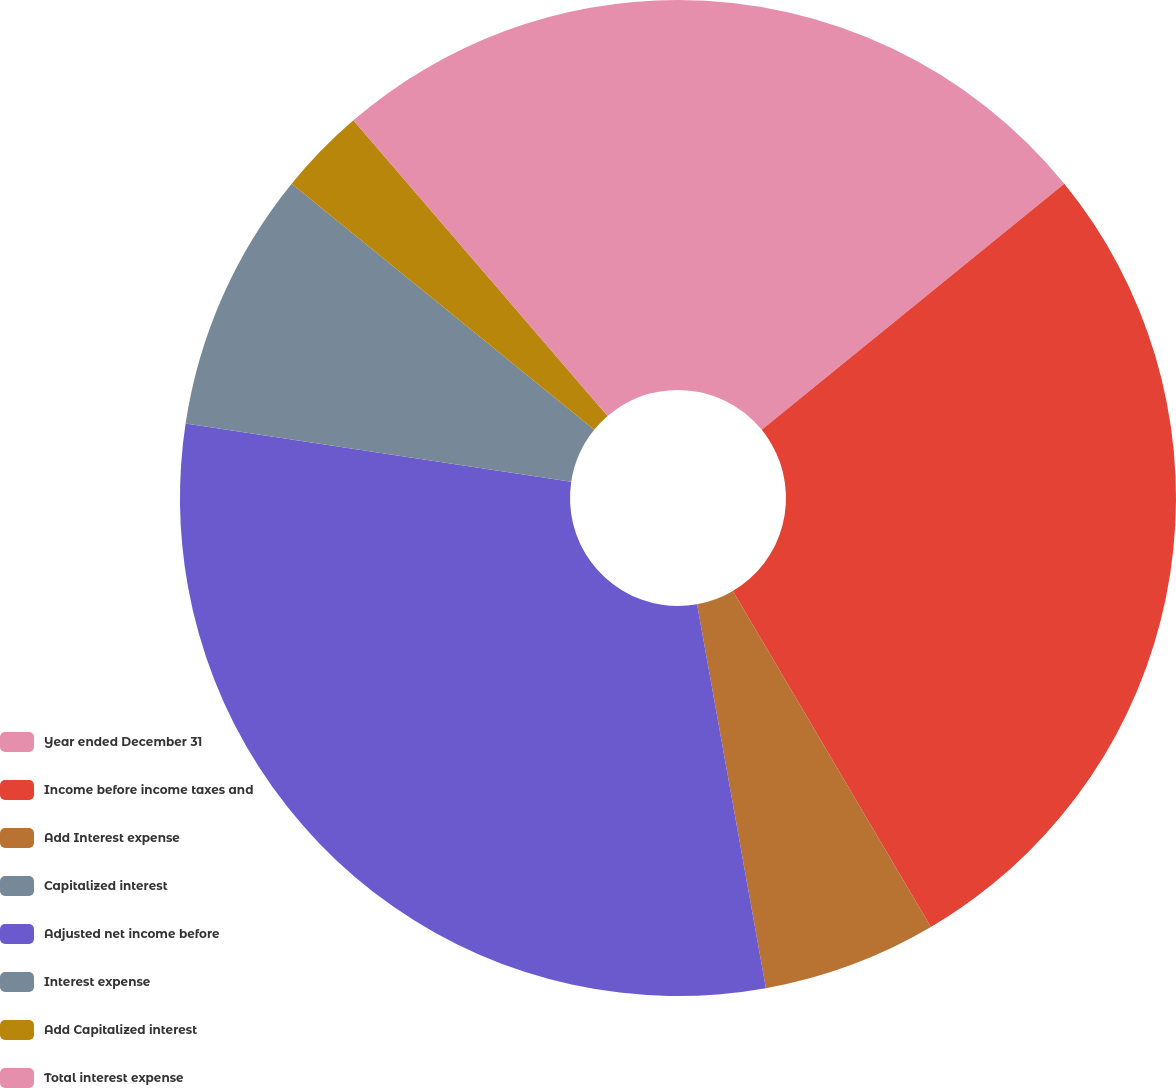Convert chart to OTSL. <chart><loc_0><loc_0><loc_500><loc_500><pie_chart><fcel>Year ended December 31<fcel>Income before income taxes and<fcel>Add Interest expense<fcel>Capitalized interest<fcel>Adjusted net income before<fcel>Interest expense<fcel>Add Capitalized interest<fcel>Total interest expense<nl><fcel>14.13%<fcel>27.39%<fcel>5.65%<fcel>0.0%<fcel>30.21%<fcel>8.48%<fcel>2.83%<fcel>11.3%<nl></chart> 